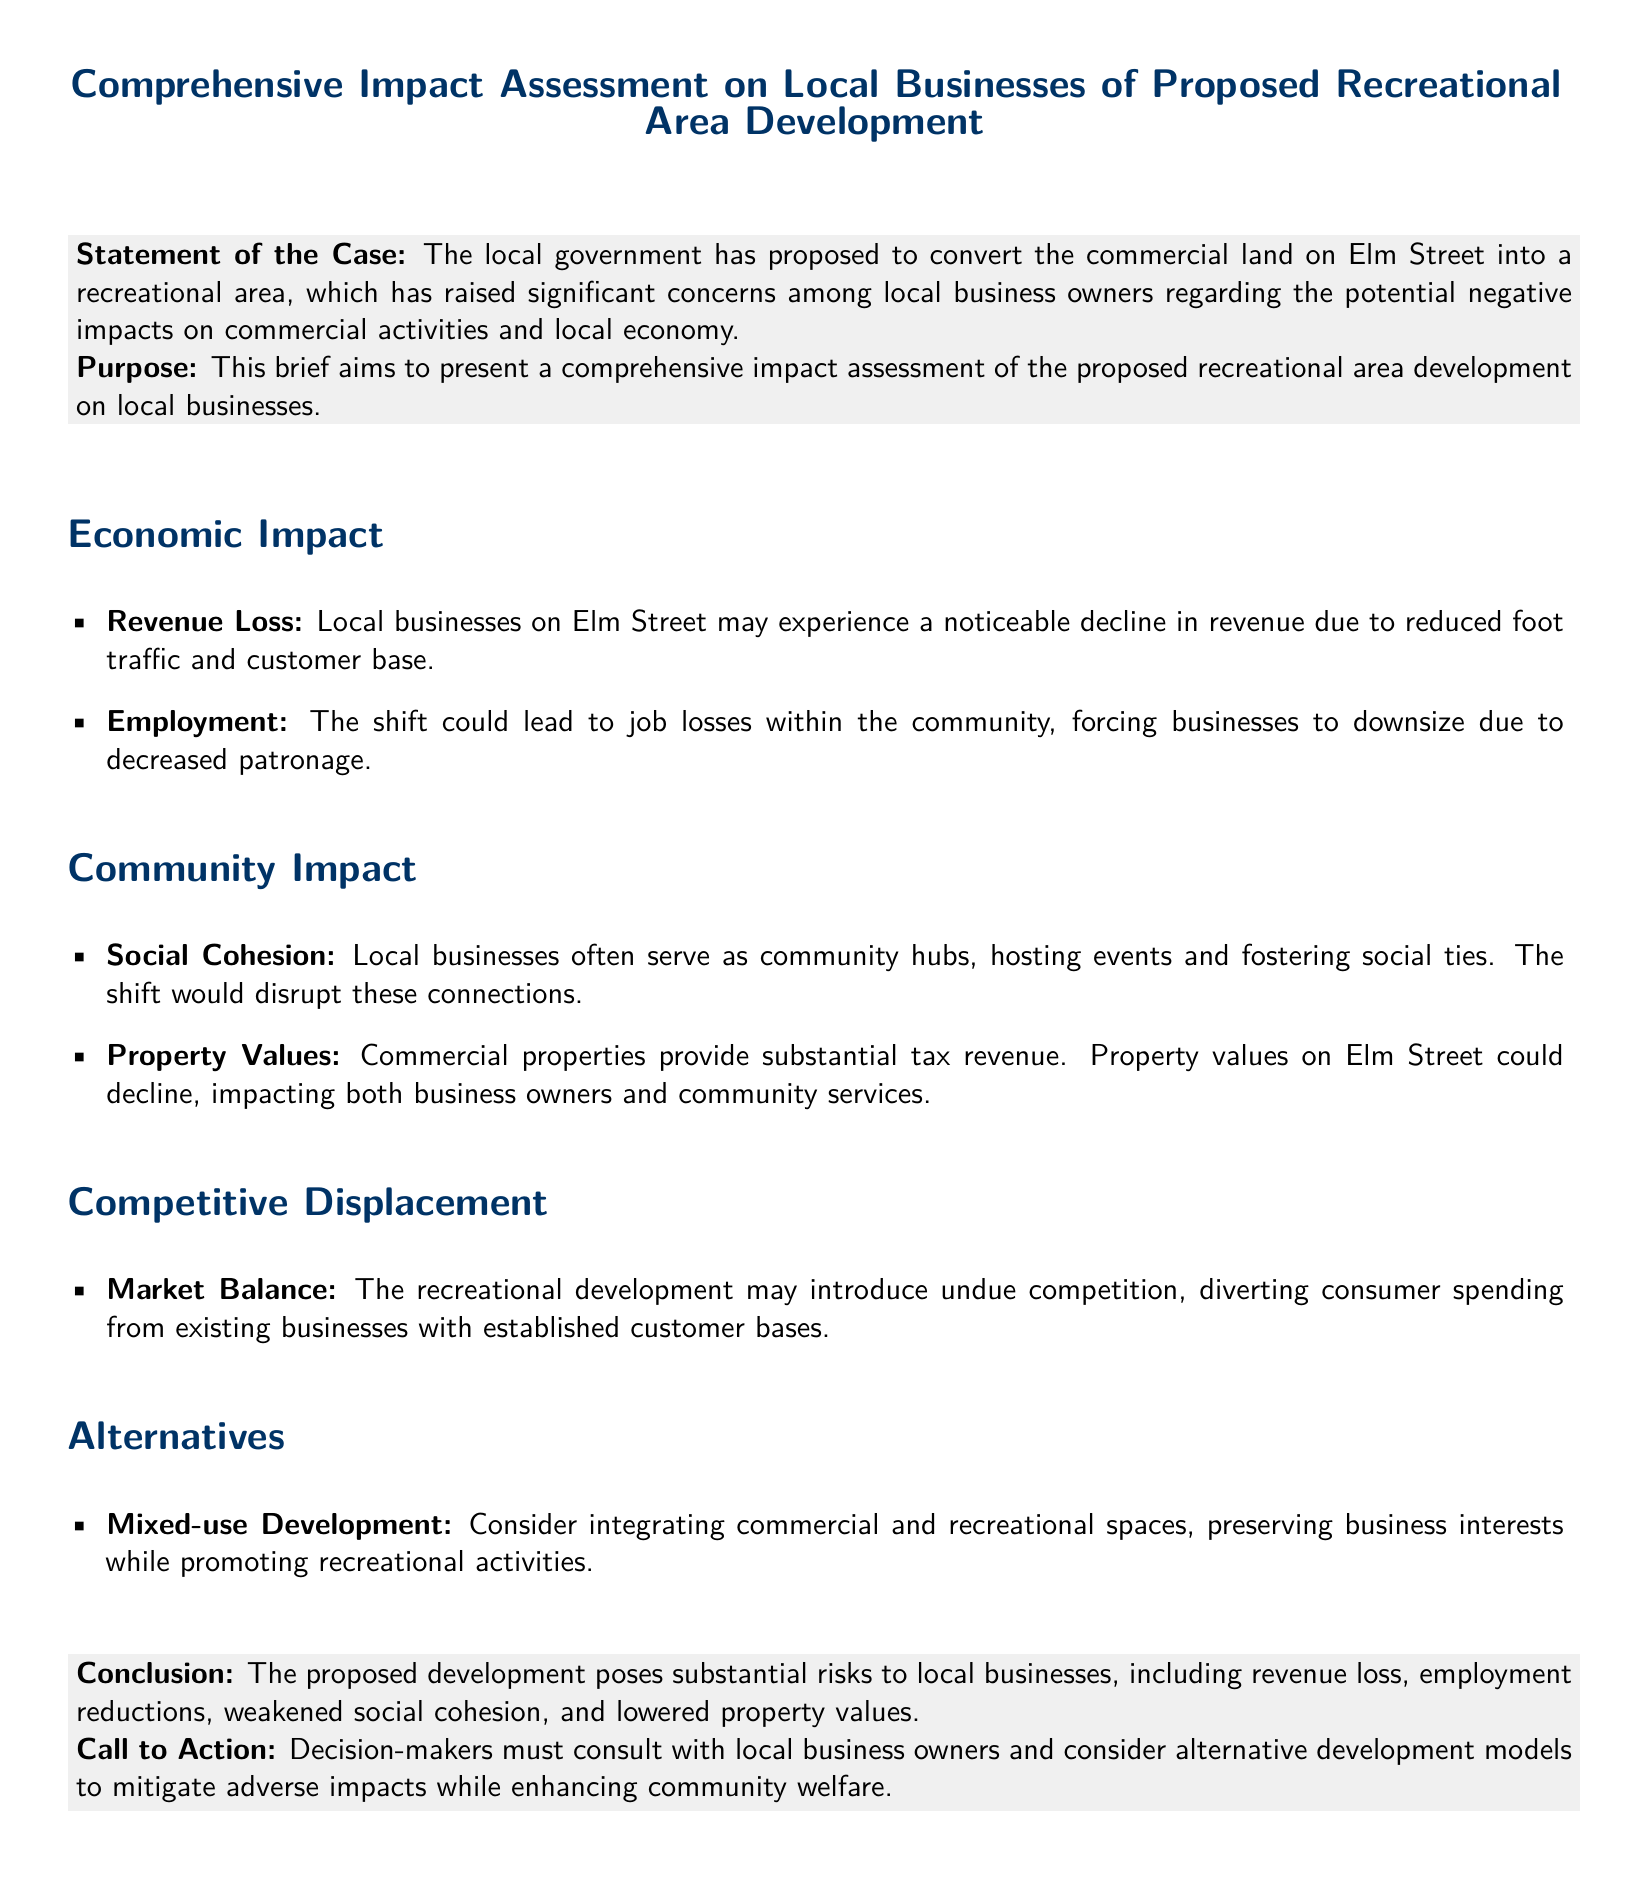What is the title of the document? The title is the main heading of the document, which states its purpose and topic.
Answer: Comprehensive Impact Assessment on Local Businesses of Proposed Recreational Area Development What street is the proposed recreational area located on? The document specifies the location of the proposed area directly in the statement of the case.
Answer: Elm Street What are two potential negative impacts mentioned about local businesses? The document lists issues under the economic impact section related to local businesses.
Answer: Revenue Loss, Employment What effect could the proposed development have on community ties? The document describes the impact on social aspects of the community under community impact.
Answer: Disrupt connections What alternative development model is suggested? The alternatives section presents other options to the proposed development for consideration.
Answer: Mixed-use Development What is the conclusion regarding the proposed development's impact? The conclusion summarizes the risks associated with the development outlined in the brief.
Answer: Substantial risks to local businesses What is the call to action in the document? The call to action outlines what decision-makers should do regarding the proposed development plan.
Answer: Consult with local business owners 